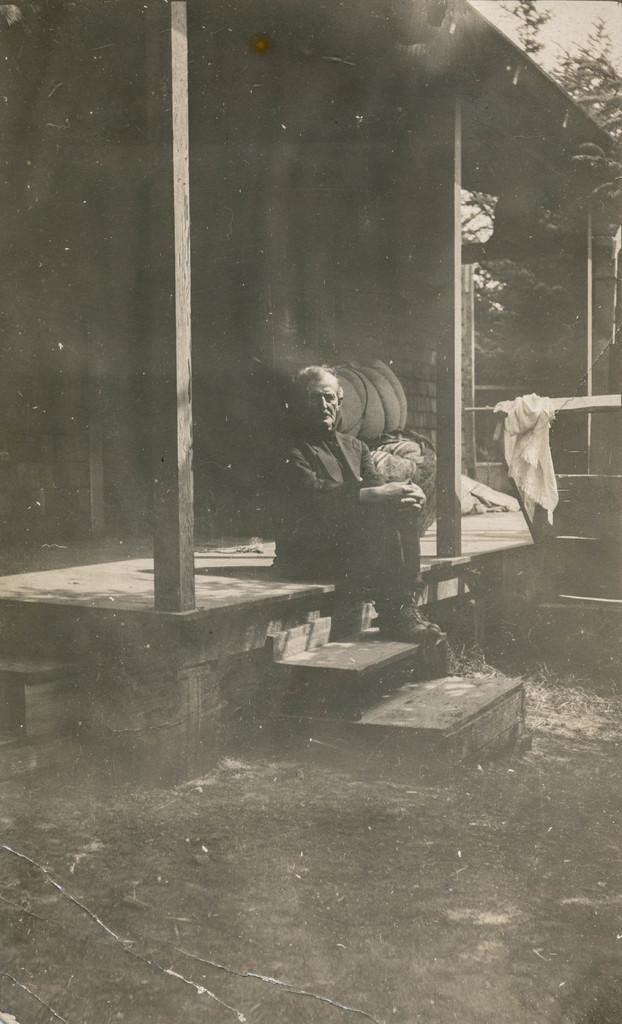What is the color scheme of the image? The image is black and white. What is the man in the image doing? The man is sitting on the floor in the image. What architectural feature can be seen in the image? There are steps visible in the image. What is the ground like in the image? The ground is visible in the image. What type of structure is present in the image? Poles are present in the image. What is the background of the image? There is a wall in the image. What type of material is visible in the image? Cloth is visible in the image. What type of shade is present in the image? There is a shade in the image. What type of vegetation is present in the image? Trees are present in the image. What is visible in the sky in the image? The sky is visible in the image. How many plastic items can be seen in the image? There are no plastic items present in the image. --- Facts: 1. There is a man standing in the image. 12. There is a woman sitting in the image. 13. There is a table in the image. 14. There is a plate of food on the table. 15. There is a glass of water on the table. 16. There is a fork and knife on the table. 17. There is a vase of flowers on the table. 18. There is a painting hanging on the wall. 19. There is a window in the image. 120. There is a curtain associated with the window. 121. There is a tree visible through the window. 122. There is a sky visible through the window. Conversation: What is the man doing in the image? The man is standing in the image. What is the woman doing in the image? The woman is sitting in the image. What is on the table in the image? There is a plate of food, a glass of water, a fork, a knife, and a vase of flowers on the table in the image. What is hanging on the wall in the image? There is a painting hanging on the wall in the image. What is visible through the window in the image? There is a tree and a sky visible through the window in the image. Reasoning: Let's think step by step in order to produce the conversation. We start by identifying the main subjects in the image, which are the man and the woman. Then, we describe the 